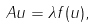<formula> <loc_0><loc_0><loc_500><loc_500>A u = \lambda f ( u ) ,</formula> 